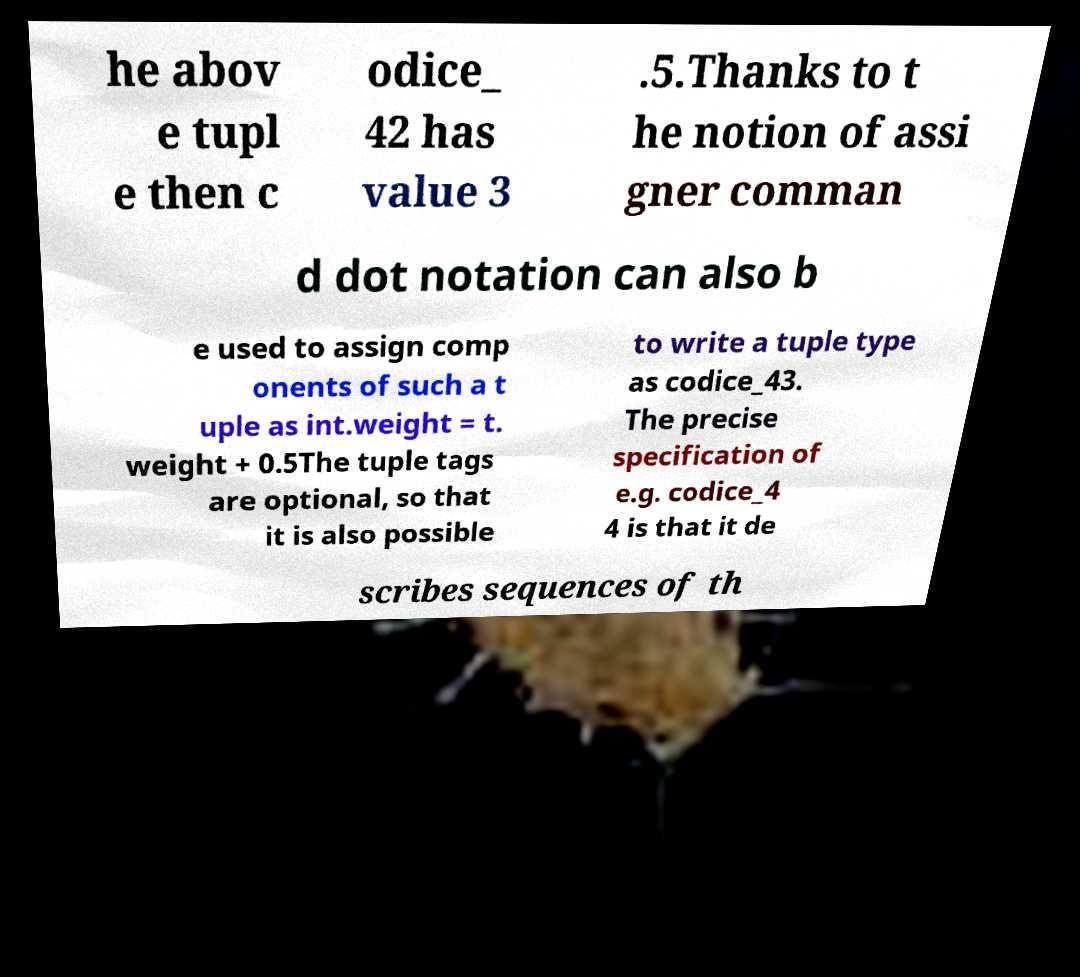Could you assist in decoding the text presented in this image and type it out clearly? he abov e tupl e then c odice_ 42 has value 3 .5.Thanks to t he notion of assi gner comman d dot notation can also b e used to assign comp onents of such a t uple as int.weight = t. weight + 0.5The tuple tags are optional, so that it is also possible to write a tuple type as codice_43. The precise specification of e.g. codice_4 4 is that it de scribes sequences of th 